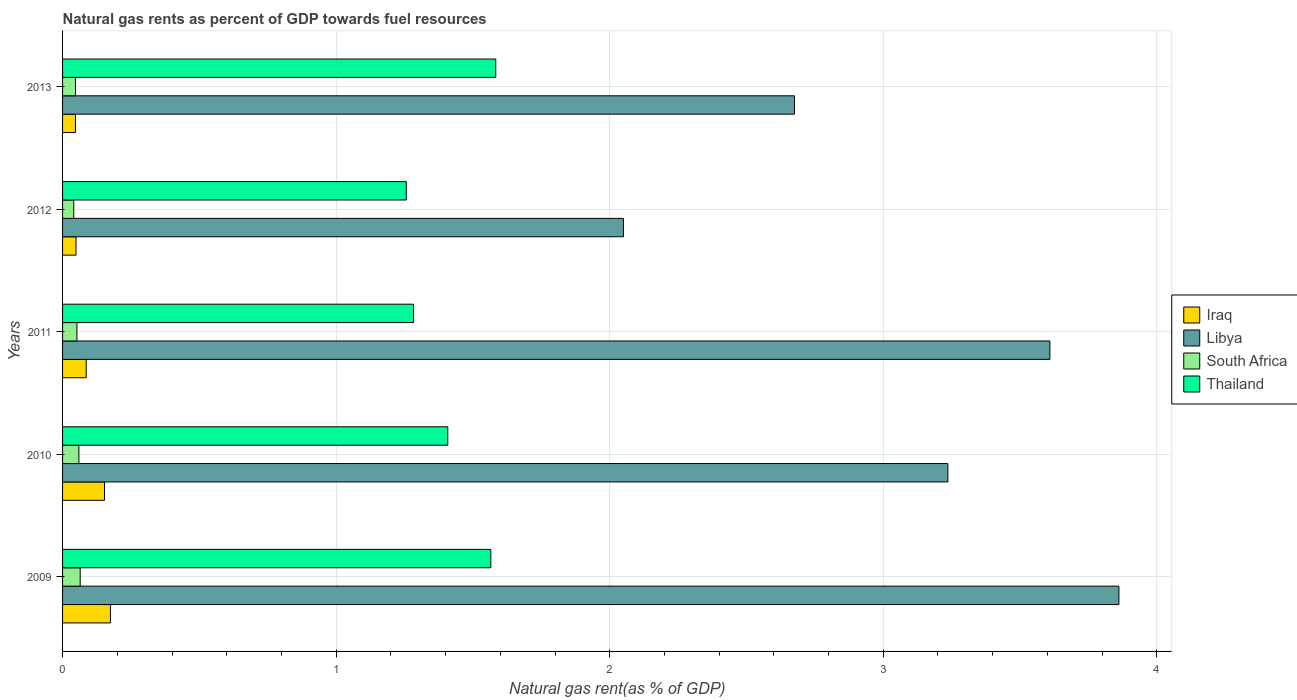How many different coloured bars are there?
Offer a terse response. 4. Are the number of bars per tick equal to the number of legend labels?
Provide a short and direct response. Yes. What is the label of the 5th group of bars from the top?
Offer a terse response. 2009. In how many cases, is the number of bars for a given year not equal to the number of legend labels?
Your response must be concise. 0. What is the natural gas rent in Libya in 2013?
Make the answer very short. 2.68. Across all years, what is the maximum natural gas rent in Thailand?
Provide a short and direct response. 1.58. Across all years, what is the minimum natural gas rent in Thailand?
Provide a short and direct response. 1.26. In which year was the natural gas rent in Thailand maximum?
Your answer should be very brief. 2013. What is the total natural gas rent in Libya in the graph?
Keep it short and to the point. 15.43. What is the difference between the natural gas rent in Thailand in 2009 and that in 2010?
Make the answer very short. 0.16. What is the difference between the natural gas rent in Thailand in 2010 and the natural gas rent in Libya in 2009?
Keep it short and to the point. -2.45. What is the average natural gas rent in Thailand per year?
Provide a short and direct response. 1.42. In the year 2011, what is the difference between the natural gas rent in Thailand and natural gas rent in South Africa?
Offer a very short reply. 1.23. In how many years, is the natural gas rent in South Africa greater than 0.4 %?
Make the answer very short. 0. What is the ratio of the natural gas rent in Iraq in 2011 to that in 2013?
Give a very brief answer. 1.84. Is the natural gas rent in Iraq in 2009 less than that in 2012?
Your response must be concise. No. What is the difference between the highest and the second highest natural gas rent in South Africa?
Provide a short and direct response. 0. What is the difference between the highest and the lowest natural gas rent in Thailand?
Offer a terse response. 0.33. In how many years, is the natural gas rent in Iraq greater than the average natural gas rent in Iraq taken over all years?
Your answer should be very brief. 2. Is it the case that in every year, the sum of the natural gas rent in South Africa and natural gas rent in Libya is greater than the sum of natural gas rent in Iraq and natural gas rent in Thailand?
Your response must be concise. Yes. What does the 3rd bar from the top in 2009 represents?
Make the answer very short. Libya. What does the 2nd bar from the bottom in 2013 represents?
Your response must be concise. Libya. Is it the case that in every year, the sum of the natural gas rent in Libya and natural gas rent in South Africa is greater than the natural gas rent in Thailand?
Your response must be concise. Yes. What is the difference between two consecutive major ticks on the X-axis?
Keep it short and to the point. 1. Are the values on the major ticks of X-axis written in scientific E-notation?
Provide a short and direct response. No. How many legend labels are there?
Give a very brief answer. 4. What is the title of the graph?
Provide a succinct answer. Natural gas rents as percent of GDP towards fuel resources. What is the label or title of the X-axis?
Provide a succinct answer. Natural gas rent(as % of GDP). What is the Natural gas rent(as % of GDP) of Iraq in 2009?
Offer a very short reply. 0.17. What is the Natural gas rent(as % of GDP) of Libya in 2009?
Offer a very short reply. 3.86. What is the Natural gas rent(as % of GDP) in South Africa in 2009?
Provide a succinct answer. 0.06. What is the Natural gas rent(as % of GDP) in Thailand in 2009?
Ensure brevity in your answer.  1.57. What is the Natural gas rent(as % of GDP) in Iraq in 2010?
Give a very brief answer. 0.15. What is the Natural gas rent(as % of GDP) of Libya in 2010?
Provide a short and direct response. 3.24. What is the Natural gas rent(as % of GDP) of South Africa in 2010?
Provide a short and direct response. 0.06. What is the Natural gas rent(as % of GDP) in Thailand in 2010?
Your answer should be compact. 1.41. What is the Natural gas rent(as % of GDP) in Iraq in 2011?
Offer a very short reply. 0.09. What is the Natural gas rent(as % of GDP) of Libya in 2011?
Your answer should be very brief. 3.61. What is the Natural gas rent(as % of GDP) in South Africa in 2011?
Offer a very short reply. 0.05. What is the Natural gas rent(as % of GDP) of Thailand in 2011?
Make the answer very short. 1.28. What is the Natural gas rent(as % of GDP) in Iraq in 2012?
Keep it short and to the point. 0.05. What is the Natural gas rent(as % of GDP) in Libya in 2012?
Ensure brevity in your answer.  2.05. What is the Natural gas rent(as % of GDP) in South Africa in 2012?
Your answer should be very brief. 0.04. What is the Natural gas rent(as % of GDP) of Thailand in 2012?
Keep it short and to the point. 1.26. What is the Natural gas rent(as % of GDP) in Iraq in 2013?
Offer a terse response. 0.05. What is the Natural gas rent(as % of GDP) of Libya in 2013?
Your answer should be very brief. 2.68. What is the Natural gas rent(as % of GDP) of South Africa in 2013?
Your response must be concise. 0.05. What is the Natural gas rent(as % of GDP) in Thailand in 2013?
Give a very brief answer. 1.58. Across all years, what is the maximum Natural gas rent(as % of GDP) of Iraq?
Give a very brief answer. 0.17. Across all years, what is the maximum Natural gas rent(as % of GDP) in Libya?
Your answer should be compact. 3.86. Across all years, what is the maximum Natural gas rent(as % of GDP) of South Africa?
Give a very brief answer. 0.06. Across all years, what is the maximum Natural gas rent(as % of GDP) of Thailand?
Keep it short and to the point. 1.58. Across all years, what is the minimum Natural gas rent(as % of GDP) in Iraq?
Your response must be concise. 0.05. Across all years, what is the minimum Natural gas rent(as % of GDP) of Libya?
Provide a succinct answer. 2.05. Across all years, what is the minimum Natural gas rent(as % of GDP) in South Africa?
Ensure brevity in your answer.  0.04. Across all years, what is the minimum Natural gas rent(as % of GDP) in Thailand?
Make the answer very short. 1.26. What is the total Natural gas rent(as % of GDP) in Iraq in the graph?
Provide a succinct answer. 0.51. What is the total Natural gas rent(as % of GDP) of Libya in the graph?
Make the answer very short. 15.43. What is the total Natural gas rent(as % of GDP) in South Africa in the graph?
Your response must be concise. 0.26. What is the total Natural gas rent(as % of GDP) of Thailand in the graph?
Your answer should be compact. 7.1. What is the difference between the Natural gas rent(as % of GDP) in Iraq in 2009 and that in 2010?
Ensure brevity in your answer.  0.02. What is the difference between the Natural gas rent(as % of GDP) of Libya in 2009 and that in 2010?
Ensure brevity in your answer.  0.63. What is the difference between the Natural gas rent(as % of GDP) in South Africa in 2009 and that in 2010?
Offer a terse response. 0. What is the difference between the Natural gas rent(as % of GDP) of Thailand in 2009 and that in 2010?
Give a very brief answer. 0.16. What is the difference between the Natural gas rent(as % of GDP) in Iraq in 2009 and that in 2011?
Give a very brief answer. 0.09. What is the difference between the Natural gas rent(as % of GDP) in Libya in 2009 and that in 2011?
Provide a short and direct response. 0.25. What is the difference between the Natural gas rent(as % of GDP) in South Africa in 2009 and that in 2011?
Your answer should be very brief. 0.01. What is the difference between the Natural gas rent(as % of GDP) of Thailand in 2009 and that in 2011?
Offer a terse response. 0.28. What is the difference between the Natural gas rent(as % of GDP) in Iraq in 2009 and that in 2012?
Make the answer very short. 0.13. What is the difference between the Natural gas rent(as % of GDP) in Libya in 2009 and that in 2012?
Provide a succinct answer. 1.81. What is the difference between the Natural gas rent(as % of GDP) of South Africa in 2009 and that in 2012?
Ensure brevity in your answer.  0.02. What is the difference between the Natural gas rent(as % of GDP) in Thailand in 2009 and that in 2012?
Offer a terse response. 0.31. What is the difference between the Natural gas rent(as % of GDP) of Iraq in 2009 and that in 2013?
Your answer should be compact. 0.13. What is the difference between the Natural gas rent(as % of GDP) in Libya in 2009 and that in 2013?
Ensure brevity in your answer.  1.19. What is the difference between the Natural gas rent(as % of GDP) in South Africa in 2009 and that in 2013?
Offer a very short reply. 0.02. What is the difference between the Natural gas rent(as % of GDP) in Thailand in 2009 and that in 2013?
Your response must be concise. -0.02. What is the difference between the Natural gas rent(as % of GDP) of Iraq in 2010 and that in 2011?
Your answer should be compact. 0.07. What is the difference between the Natural gas rent(as % of GDP) of Libya in 2010 and that in 2011?
Ensure brevity in your answer.  -0.37. What is the difference between the Natural gas rent(as % of GDP) of South Africa in 2010 and that in 2011?
Your answer should be compact. 0.01. What is the difference between the Natural gas rent(as % of GDP) of Thailand in 2010 and that in 2011?
Your answer should be very brief. 0.13. What is the difference between the Natural gas rent(as % of GDP) of Iraq in 2010 and that in 2012?
Your response must be concise. 0.1. What is the difference between the Natural gas rent(as % of GDP) of Libya in 2010 and that in 2012?
Offer a terse response. 1.19. What is the difference between the Natural gas rent(as % of GDP) of South Africa in 2010 and that in 2012?
Provide a succinct answer. 0.02. What is the difference between the Natural gas rent(as % of GDP) in Thailand in 2010 and that in 2012?
Offer a terse response. 0.15. What is the difference between the Natural gas rent(as % of GDP) in Iraq in 2010 and that in 2013?
Your response must be concise. 0.11. What is the difference between the Natural gas rent(as % of GDP) in Libya in 2010 and that in 2013?
Ensure brevity in your answer.  0.56. What is the difference between the Natural gas rent(as % of GDP) in South Africa in 2010 and that in 2013?
Ensure brevity in your answer.  0.01. What is the difference between the Natural gas rent(as % of GDP) in Thailand in 2010 and that in 2013?
Your answer should be very brief. -0.18. What is the difference between the Natural gas rent(as % of GDP) of Iraq in 2011 and that in 2012?
Give a very brief answer. 0.04. What is the difference between the Natural gas rent(as % of GDP) of Libya in 2011 and that in 2012?
Provide a short and direct response. 1.56. What is the difference between the Natural gas rent(as % of GDP) in South Africa in 2011 and that in 2012?
Keep it short and to the point. 0.01. What is the difference between the Natural gas rent(as % of GDP) in Thailand in 2011 and that in 2012?
Offer a terse response. 0.03. What is the difference between the Natural gas rent(as % of GDP) in Iraq in 2011 and that in 2013?
Your answer should be compact. 0.04. What is the difference between the Natural gas rent(as % of GDP) in Libya in 2011 and that in 2013?
Provide a succinct answer. 0.93. What is the difference between the Natural gas rent(as % of GDP) in South Africa in 2011 and that in 2013?
Provide a succinct answer. 0.01. What is the difference between the Natural gas rent(as % of GDP) of Thailand in 2011 and that in 2013?
Offer a very short reply. -0.3. What is the difference between the Natural gas rent(as % of GDP) of Iraq in 2012 and that in 2013?
Keep it short and to the point. 0. What is the difference between the Natural gas rent(as % of GDP) in Libya in 2012 and that in 2013?
Your answer should be very brief. -0.63. What is the difference between the Natural gas rent(as % of GDP) of South Africa in 2012 and that in 2013?
Your answer should be compact. -0.01. What is the difference between the Natural gas rent(as % of GDP) in Thailand in 2012 and that in 2013?
Provide a short and direct response. -0.33. What is the difference between the Natural gas rent(as % of GDP) of Iraq in 2009 and the Natural gas rent(as % of GDP) of Libya in 2010?
Provide a short and direct response. -3.06. What is the difference between the Natural gas rent(as % of GDP) in Iraq in 2009 and the Natural gas rent(as % of GDP) in South Africa in 2010?
Ensure brevity in your answer.  0.12. What is the difference between the Natural gas rent(as % of GDP) of Iraq in 2009 and the Natural gas rent(as % of GDP) of Thailand in 2010?
Your response must be concise. -1.23. What is the difference between the Natural gas rent(as % of GDP) of Libya in 2009 and the Natural gas rent(as % of GDP) of South Africa in 2010?
Offer a very short reply. 3.8. What is the difference between the Natural gas rent(as % of GDP) in Libya in 2009 and the Natural gas rent(as % of GDP) in Thailand in 2010?
Offer a very short reply. 2.45. What is the difference between the Natural gas rent(as % of GDP) of South Africa in 2009 and the Natural gas rent(as % of GDP) of Thailand in 2010?
Provide a short and direct response. -1.34. What is the difference between the Natural gas rent(as % of GDP) of Iraq in 2009 and the Natural gas rent(as % of GDP) of Libya in 2011?
Keep it short and to the point. -3.43. What is the difference between the Natural gas rent(as % of GDP) in Iraq in 2009 and the Natural gas rent(as % of GDP) in South Africa in 2011?
Give a very brief answer. 0.12. What is the difference between the Natural gas rent(as % of GDP) in Iraq in 2009 and the Natural gas rent(as % of GDP) in Thailand in 2011?
Provide a short and direct response. -1.11. What is the difference between the Natural gas rent(as % of GDP) of Libya in 2009 and the Natural gas rent(as % of GDP) of South Africa in 2011?
Offer a terse response. 3.81. What is the difference between the Natural gas rent(as % of GDP) of Libya in 2009 and the Natural gas rent(as % of GDP) of Thailand in 2011?
Ensure brevity in your answer.  2.58. What is the difference between the Natural gas rent(as % of GDP) of South Africa in 2009 and the Natural gas rent(as % of GDP) of Thailand in 2011?
Make the answer very short. -1.22. What is the difference between the Natural gas rent(as % of GDP) in Iraq in 2009 and the Natural gas rent(as % of GDP) in Libya in 2012?
Your response must be concise. -1.88. What is the difference between the Natural gas rent(as % of GDP) of Iraq in 2009 and the Natural gas rent(as % of GDP) of South Africa in 2012?
Provide a succinct answer. 0.13. What is the difference between the Natural gas rent(as % of GDP) of Iraq in 2009 and the Natural gas rent(as % of GDP) of Thailand in 2012?
Provide a succinct answer. -1.08. What is the difference between the Natural gas rent(as % of GDP) of Libya in 2009 and the Natural gas rent(as % of GDP) of South Africa in 2012?
Your answer should be very brief. 3.82. What is the difference between the Natural gas rent(as % of GDP) in Libya in 2009 and the Natural gas rent(as % of GDP) in Thailand in 2012?
Keep it short and to the point. 2.6. What is the difference between the Natural gas rent(as % of GDP) in South Africa in 2009 and the Natural gas rent(as % of GDP) in Thailand in 2012?
Make the answer very short. -1.19. What is the difference between the Natural gas rent(as % of GDP) in Iraq in 2009 and the Natural gas rent(as % of GDP) in Libya in 2013?
Ensure brevity in your answer.  -2.5. What is the difference between the Natural gas rent(as % of GDP) in Iraq in 2009 and the Natural gas rent(as % of GDP) in South Africa in 2013?
Offer a very short reply. 0.13. What is the difference between the Natural gas rent(as % of GDP) in Iraq in 2009 and the Natural gas rent(as % of GDP) in Thailand in 2013?
Provide a succinct answer. -1.41. What is the difference between the Natural gas rent(as % of GDP) of Libya in 2009 and the Natural gas rent(as % of GDP) of South Africa in 2013?
Make the answer very short. 3.81. What is the difference between the Natural gas rent(as % of GDP) of Libya in 2009 and the Natural gas rent(as % of GDP) of Thailand in 2013?
Ensure brevity in your answer.  2.28. What is the difference between the Natural gas rent(as % of GDP) in South Africa in 2009 and the Natural gas rent(as % of GDP) in Thailand in 2013?
Offer a very short reply. -1.52. What is the difference between the Natural gas rent(as % of GDP) in Iraq in 2010 and the Natural gas rent(as % of GDP) in Libya in 2011?
Provide a succinct answer. -3.46. What is the difference between the Natural gas rent(as % of GDP) of Iraq in 2010 and the Natural gas rent(as % of GDP) of South Africa in 2011?
Your response must be concise. 0.1. What is the difference between the Natural gas rent(as % of GDP) of Iraq in 2010 and the Natural gas rent(as % of GDP) of Thailand in 2011?
Give a very brief answer. -1.13. What is the difference between the Natural gas rent(as % of GDP) in Libya in 2010 and the Natural gas rent(as % of GDP) in South Africa in 2011?
Provide a succinct answer. 3.18. What is the difference between the Natural gas rent(as % of GDP) in Libya in 2010 and the Natural gas rent(as % of GDP) in Thailand in 2011?
Keep it short and to the point. 1.95. What is the difference between the Natural gas rent(as % of GDP) of South Africa in 2010 and the Natural gas rent(as % of GDP) of Thailand in 2011?
Give a very brief answer. -1.22. What is the difference between the Natural gas rent(as % of GDP) in Iraq in 2010 and the Natural gas rent(as % of GDP) in Libya in 2012?
Your answer should be compact. -1.9. What is the difference between the Natural gas rent(as % of GDP) in Iraq in 2010 and the Natural gas rent(as % of GDP) in South Africa in 2012?
Offer a very short reply. 0.11. What is the difference between the Natural gas rent(as % of GDP) in Iraq in 2010 and the Natural gas rent(as % of GDP) in Thailand in 2012?
Provide a succinct answer. -1.1. What is the difference between the Natural gas rent(as % of GDP) in Libya in 2010 and the Natural gas rent(as % of GDP) in South Africa in 2012?
Ensure brevity in your answer.  3.2. What is the difference between the Natural gas rent(as % of GDP) of Libya in 2010 and the Natural gas rent(as % of GDP) of Thailand in 2012?
Your answer should be compact. 1.98. What is the difference between the Natural gas rent(as % of GDP) in South Africa in 2010 and the Natural gas rent(as % of GDP) in Thailand in 2012?
Ensure brevity in your answer.  -1.2. What is the difference between the Natural gas rent(as % of GDP) of Iraq in 2010 and the Natural gas rent(as % of GDP) of Libya in 2013?
Offer a very short reply. -2.52. What is the difference between the Natural gas rent(as % of GDP) in Iraq in 2010 and the Natural gas rent(as % of GDP) in South Africa in 2013?
Your answer should be very brief. 0.11. What is the difference between the Natural gas rent(as % of GDP) in Iraq in 2010 and the Natural gas rent(as % of GDP) in Thailand in 2013?
Ensure brevity in your answer.  -1.43. What is the difference between the Natural gas rent(as % of GDP) in Libya in 2010 and the Natural gas rent(as % of GDP) in South Africa in 2013?
Offer a very short reply. 3.19. What is the difference between the Natural gas rent(as % of GDP) in Libya in 2010 and the Natural gas rent(as % of GDP) in Thailand in 2013?
Offer a terse response. 1.65. What is the difference between the Natural gas rent(as % of GDP) of South Africa in 2010 and the Natural gas rent(as % of GDP) of Thailand in 2013?
Offer a very short reply. -1.52. What is the difference between the Natural gas rent(as % of GDP) in Iraq in 2011 and the Natural gas rent(as % of GDP) in Libya in 2012?
Offer a very short reply. -1.96. What is the difference between the Natural gas rent(as % of GDP) of Iraq in 2011 and the Natural gas rent(as % of GDP) of South Africa in 2012?
Offer a terse response. 0.05. What is the difference between the Natural gas rent(as % of GDP) of Iraq in 2011 and the Natural gas rent(as % of GDP) of Thailand in 2012?
Provide a short and direct response. -1.17. What is the difference between the Natural gas rent(as % of GDP) of Libya in 2011 and the Natural gas rent(as % of GDP) of South Africa in 2012?
Your answer should be very brief. 3.57. What is the difference between the Natural gas rent(as % of GDP) in Libya in 2011 and the Natural gas rent(as % of GDP) in Thailand in 2012?
Offer a very short reply. 2.35. What is the difference between the Natural gas rent(as % of GDP) of South Africa in 2011 and the Natural gas rent(as % of GDP) of Thailand in 2012?
Offer a very short reply. -1.2. What is the difference between the Natural gas rent(as % of GDP) of Iraq in 2011 and the Natural gas rent(as % of GDP) of Libya in 2013?
Keep it short and to the point. -2.59. What is the difference between the Natural gas rent(as % of GDP) in Iraq in 2011 and the Natural gas rent(as % of GDP) in South Africa in 2013?
Offer a terse response. 0.04. What is the difference between the Natural gas rent(as % of GDP) of Iraq in 2011 and the Natural gas rent(as % of GDP) of Thailand in 2013?
Offer a terse response. -1.5. What is the difference between the Natural gas rent(as % of GDP) of Libya in 2011 and the Natural gas rent(as % of GDP) of South Africa in 2013?
Keep it short and to the point. 3.56. What is the difference between the Natural gas rent(as % of GDP) of Libya in 2011 and the Natural gas rent(as % of GDP) of Thailand in 2013?
Provide a succinct answer. 2.03. What is the difference between the Natural gas rent(as % of GDP) in South Africa in 2011 and the Natural gas rent(as % of GDP) in Thailand in 2013?
Your response must be concise. -1.53. What is the difference between the Natural gas rent(as % of GDP) of Iraq in 2012 and the Natural gas rent(as % of GDP) of Libya in 2013?
Your response must be concise. -2.63. What is the difference between the Natural gas rent(as % of GDP) of Iraq in 2012 and the Natural gas rent(as % of GDP) of South Africa in 2013?
Provide a short and direct response. 0. What is the difference between the Natural gas rent(as % of GDP) of Iraq in 2012 and the Natural gas rent(as % of GDP) of Thailand in 2013?
Your answer should be compact. -1.53. What is the difference between the Natural gas rent(as % of GDP) in Libya in 2012 and the Natural gas rent(as % of GDP) in South Africa in 2013?
Keep it short and to the point. 2. What is the difference between the Natural gas rent(as % of GDP) in Libya in 2012 and the Natural gas rent(as % of GDP) in Thailand in 2013?
Give a very brief answer. 0.47. What is the difference between the Natural gas rent(as % of GDP) in South Africa in 2012 and the Natural gas rent(as % of GDP) in Thailand in 2013?
Ensure brevity in your answer.  -1.54. What is the average Natural gas rent(as % of GDP) of Iraq per year?
Your response must be concise. 0.1. What is the average Natural gas rent(as % of GDP) in Libya per year?
Make the answer very short. 3.09. What is the average Natural gas rent(as % of GDP) of South Africa per year?
Offer a terse response. 0.05. What is the average Natural gas rent(as % of GDP) of Thailand per year?
Give a very brief answer. 1.42. In the year 2009, what is the difference between the Natural gas rent(as % of GDP) of Iraq and Natural gas rent(as % of GDP) of Libya?
Your answer should be very brief. -3.69. In the year 2009, what is the difference between the Natural gas rent(as % of GDP) of Iraq and Natural gas rent(as % of GDP) of South Africa?
Your answer should be compact. 0.11. In the year 2009, what is the difference between the Natural gas rent(as % of GDP) of Iraq and Natural gas rent(as % of GDP) of Thailand?
Make the answer very short. -1.39. In the year 2009, what is the difference between the Natural gas rent(as % of GDP) in Libya and Natural gas rent(as % of GDP) in South Africa?
Your answer should be compact. 3.8. In the year 2009, what is the difference between the Natural gas rent(as % of GDP) in Libya and Natural gas rent(as % of GDP) in Thailand?
Ensure brevity in your answer.  2.3. In the year 2009, what is the difference between the Natural gas rent(as % of GDP) of South Africa and Natural gas rent(as % of GDP) of Thailand?
Ensure brevity in your answer.  -1.5. In the year 2010, what is the difference between the Natural gas rent(as % of GDP) of Iraq and Natural gas rent(as % of GDP) of Libya?
Your answer should be very brief. -3.08. In the year 2010, what is the difference between the Natural gas rent(as % of GDP) in Iraq and Natural gas rent(as % of GDP) in South Africa?
Offer a very short reply. 0.09. In the year 2010, what is the difference between the Natural gas rent(as % of GDP) in Iraq and Natural gas rent(as % of GDP) in Thailand?
Your response must be concise. -1.25. In the year 2010, what is the difference between the Natural gas rent(as % of GDP) of Libya and Natural gas rent(as % of GDP) of South Africa?
Your answer should be very brief. 3.18. In the year 2010, what is the difference between the Natural gas rent(as % of GDP) in Libya and Natural gas rent(as % of GDP) in Thailand?
Your answer should be compact. 1.83. In the year 2010, what is the difference between the Natural gas rent(as % of GDP) of South Africa and Natural gas rent(as % of GDP) of Thailand?
Give a very brief answer. -1.35. In the year 2011, what is the difference between the Natural gas rent(as % of GDP) of Iraq and Natural gas rent(as % of GDP) of Libya?
Give a very brief answer. -3.52. In the year 2011, what is the difference between the Natural gas rent(as % of GDP) of Iraq and Natural gas rent(as % of GDP) of South Africa?
Keep it short and to the point. 0.03. In the year 2011, what is the difference between the Natural gas rent(as % of GDP) of Iraq and Natural gas rent(as % of GDP) of Thailand?
Ensure brevity in your answer.  -1.2. In the year 2011, what is the difference between the Natural gas rent(as % of GDP) of Libya and Natural gas rent(as % of GDP) of South Africa?
Your answer should be very brief. 3.56. In the year 2011, what is the difference between the Natural gas rent(as % of GDP) of Libya and Natural gas rent(as % of GDP) of Thailand?
Give a very brief answer. 2.33. In the year 2011, what is the difference between the Natural gas rent(as % of GDP) in South Africa and Natural gas rent(as % of GDP) in Thailand?
Provide a succinct answer. -1.23. In the year 2012, what is the difference between the Natural gas rent(as % of GDP) of Iraq and Natural gas rent(as % of GDP) of Libya?
Ensure brevity in your answer.  -2. In the year 2012, what is the difference between the Natural gas rent(as % of GDP) of Iraq and Natural gas rent(as % of GDP) of South Africa?
Your answer should be compact. 0.01. In the year 2012, what is the difference between the Natural gas rent(as % of GDP) of Iraq and Natural gas rent(as % of GDP) of Thailand?
Provide a succinct answer. -1.21. In the year 2012, what is the difference between the Natural gas rent(as % of GDP) of Libya and Natural gas rent(as % of GDP) of South Africa?
Offer a very short reply. 2.01. In the year 2012, what is the difference between the Natural gas rent(as % of GDP) of Libya and Natural gas rent(as % of GDP) of Thailand?
Provide a short and direct response. 0.79. In the year 2012, what is the difference between the Natural gas rent(as % of GDP) of South Africa and Natural gas rent(as % of GDP) of Thailand?
Offer a terse response. -1.22. In the year 2013, what is the difference between the Natural gas rent(as % of GDP) in Iraq and Natural gas rent(as % of GDP) in Libya?
Your answer should be compact. -2.63. In the year 2013, what is the difference between the Natural gas rent(as % of GDP) in Iraq and Natural gas rent(as % of GDP) in South Africa?
Provide a short and direct response. -0. In the year 2013, what is the difference between the Natural gas rent(as % of GDP) of Iraq and Natural gas rent(as % of GDP) of Thailand?
Offer a very short reply. -1.54. In the year 2013, what is the difference between the Natural gas rent(as % of GDP) of Libya and Natural gas rent(as % of GDP) of South Africa?
Provide a short and direct response. 2.63. In the year 2013, what is the difference between the Natural gas rent(as % of GDP) in Libya and Natural gas rent(as % of GDP) in Thailand?
Provide a succinct answer. 1.09. In the year 2013, what is the difference between the Natural gas rent(as % of GDP) of South Africa and Natural gas rent(as % of GDP) of Thailand?
Provide a short and direct response. -1.54. What is the ratio of the Natural gas rent(as % of GDP) of Iraq in 2009 to that in 2010?
Offer a very short reply. 1.14. What is the ratio of the Natural gas rent(as % of GDP) of Libya in 2009 to that in 2010?
Your answer should be compact. 1.19. What is the ratio of the Natural gas rent(as % of GDP) in South Africa in 2009 to that in 2010?
Offer a very short reply. 1.08. What is the ratio of the Natural gas rent(as % of GDP) in Thailand in 2009 to that in 2010?
Provide a succinct answer. 1.11. What is the ratio of the Natural gas rent(as % of GDP) of Iraq in 2009 to that in 2011?
Offer a terse response. 2.02. What is the ratio of the Natural gas rent(as % of GDP) of Libya in 2009 to that in 2011?
Give a very brief answer. 1.07. What is the ratio of the Natural gas rent(as % of GDP) in South Africa in 2009 to that in 2011?
Provide a succinct answer. 1.23. What is the ratio of the Natural gas rent(as % of GDP) in Thailand in 2009 to that in 2011?
Provide a succinct answer. 1.22. What is the ratio of the Natural gas rent(as % of GDP) of Iraq in 2009 to that in 2012?
Your response must be concise. 3.57. What is the ratio of the Natural gas rent(as % of GDP) in Libya in 2009 to that in 2012?
Offer a terse response. 1.88. What is the ratio of the Natural gas rent(as % of GDP) of South Africa in 2009 to that in 2012?
Your response must be concise. 1.58. What is the ratio of the Natural gas rent(as % of GDP) in Thailand in 2009 to that in 2012?
Provide a short and direct response. 1.25. What is the ratio of the Natural gas rent(as % of GDP) in Iraq in 2009 to that in 2013?
Offer a very short reply. 3.72. What is the ratio of the Natural gas rent(as % of GDP) in Libya in 2009 to that in 2013?
Offer a terse response. 1.44. What is the ratio of the Natural gas rent(as % of GDP) in South Africa in 2009 to that in 2013?
Provide a short and direct response. 1.37. What is the ratio of the Natural gas rent(as % of GDP) in Iraq in 2010 to that in 2011?
Provide a succinct answer. 1.77. What is the ratio of the Natural gas rent(as % of GDP) of Libya in 2010 to that in 2011?
Your answer should be very brief. 0.9. What is the ratio of the Natural gas rent(as % of GDP) of South Africa in 2010 to that in 2011?
Make the answer very short. 1.14. What is the ratio of the Natural gas rent(as % of GDP) of Thailand in 2010 to that in 2011?
Provide a short and direct response. 1.1. What is the ratio of the Natural gas rent(as % of GDP) of Iraq in 2010 to that in 2012?
Your response must be concise. 3.13. What is the ratio of the Natural gas rent(as % of GDP) of Libya in 2010 to that in 2012?
Provide a short and direct response. 1.58. What is the ratio of the Natural gas rent(as % of GDP) in South Africa in 2010 to that in 2012?
Make the answer very short. 1.46. What is the ratio of the Natural gas rent(as % of GDP) of Thailand in 2010 to that in 2012?
Your answer should be compact. 1.12. What is the ratio of the Natural gas rent(as % of GDP) of Iraq in 2010 to that in 2013?
Provide a succinct answer. 3.26. What is the ratio of the Natural gas rent(as % of GDP) in Libya in 2010 to that in 2013?
Your response must be concise. 1.21. What is the ratio of the Natural gas rent(as % of GDP) in South Africa in 2010 to that in 2013?
Provide a succinct answer. 1.27. What is the ratio of the Natural gas rent(as % of GDP) in Thailand in 2010 to that in 2013?
Your answer should be compact. 0.89. What is the ratio of the Natural gas rent(as % of GDP) of Iraq in 2011 to that in 2012?
Make the answer very short. 1.76. What is the ratio of the Natural gas rent(as % of GDP) of Libya in 2011 to that in 2012?
Ensure brevity in your answer.  1.76. What is the ratio of the Natural gas rent(as % of GDP) of Thailand in 2011 to that in 2012?
Offer a terse response. 1.02. What is the ratio of the Natural gas rent(as % of GDP) in Iraq in 2011 to that in 2013?
Your response must be concise. 1.84. What is the ratio of the Natural gas rent(as % of GDP) in Libya in 2011 to that in 2013?
Ensure brevity in your answer.  1.35. What is the ratio of the Natural gas rent(as % of GDP) in South Africa in 2011 to that in 2013?
Your answer should be compact. 1.11. What is the ratio of the Natural gas rent(as % of GDP) of Thailand in 2011 to that in 2013?
Provide a succinct answer. 0.81. What is the ratio of the Natural gas rent(as % of GDP) in Iraq in 2012 to that in 2013?
Offer a very short reply. 1.04. What is the ratio of the Natural gas rent(as % of GDP) in Libya in 2012 to that in 2013?
Ensure brevity in your answer.  0.77. What is the ratio of the Natural gas rent(as % of GDP) of South Africa in 2012 to that in 2013?
Your response must be concise. 0.87. What is the ratio of the Natural gas rent(as % of GDP) in Thailand in 2012 to that in 2013?
Your answer should be compact. 0.79. What is the difference between the highest and the second highest Natural gas rent(as % of GDP) of Iraq?
Give a very brief answer. 0.02. What is the difference between the highest and the second highest Natural gas rent(as % of GDP) of Libya?
Your answer should be very brief. 0.25. What is the difference between the highest and the second highest Natural gas rent(as % of GDP) in South Africa?
Offer a terse response. 0. What is the difference between the highest and the second highest Natural gas rent(as % of GDP) of Thailand?
Keep it short and to the point. 0.02. What is the difference between the highest and the lowest Natural gas rent(as % of GDP) in Iraq?
Give a very brief answer. 0.13. What is the difference between the highest and the lowest Natural gas rent(as % of GDP) of Libya?
Provide a succinct answer. 1.81. What is the difference between the highest and the lowest Natural gas rent(as % of GDP) of South Africa?
Make the answer very short. 0.02. What is the difference between the highest and the lowest Natural gas rent(as % of GDP) of Thailand?
Your answer should be very brief. 0.33. 